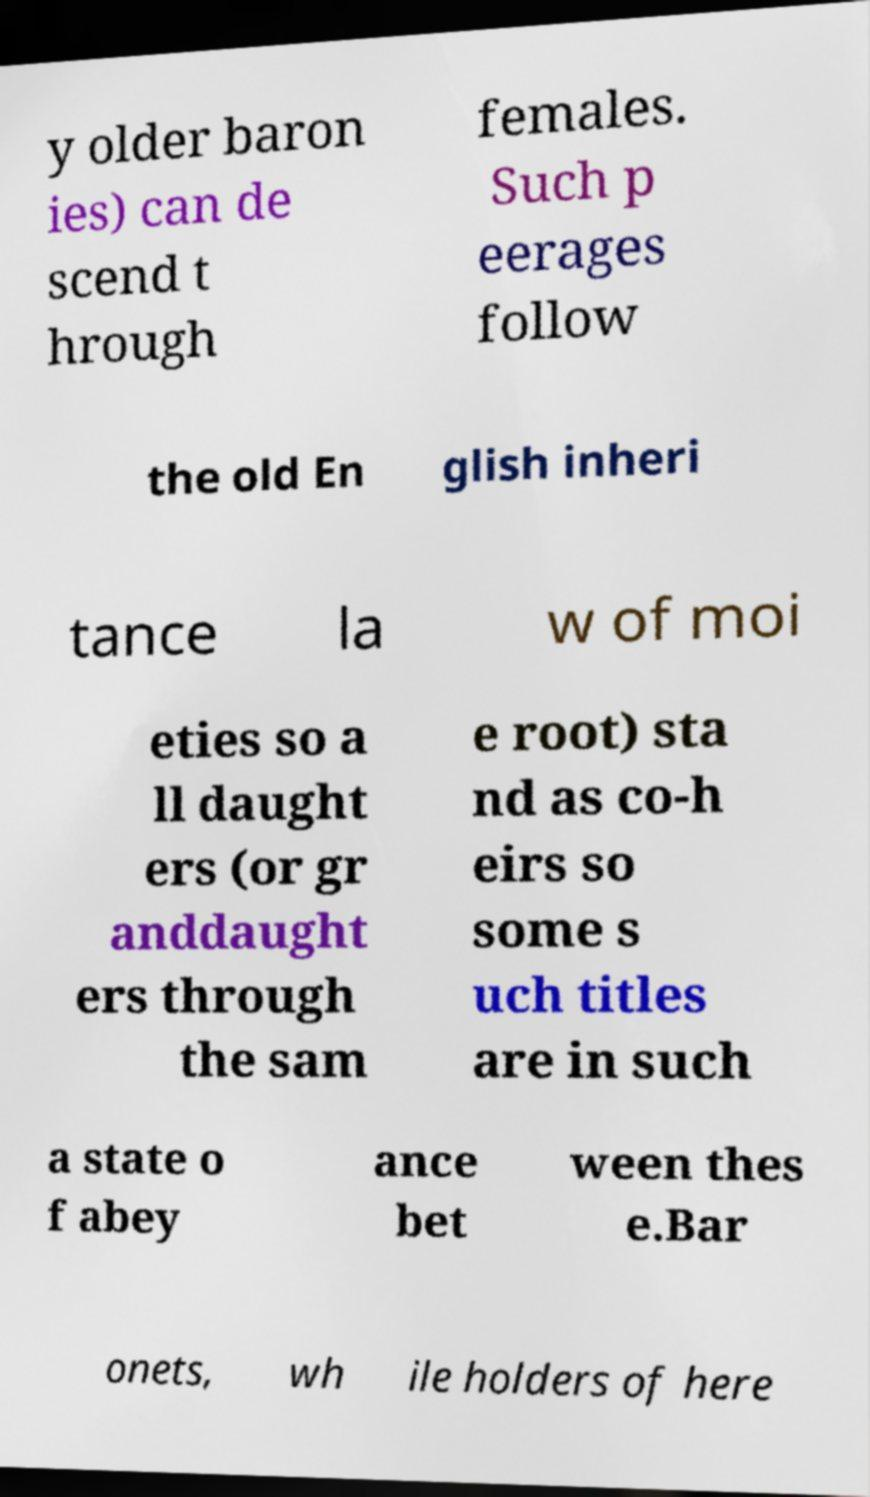Could you extract and type out the text from this image? y older baron ies) can de scend t hrough females. Such p eerages follow the old En glish inheri tance la w of moi eties so a ll daught ers (or gr anddaught ers through the sam e root) sta nd as co-h eirs so some s uch titles are in such a state o f abey ance bet ween thes e.Bar onets, wh ile holders of here 